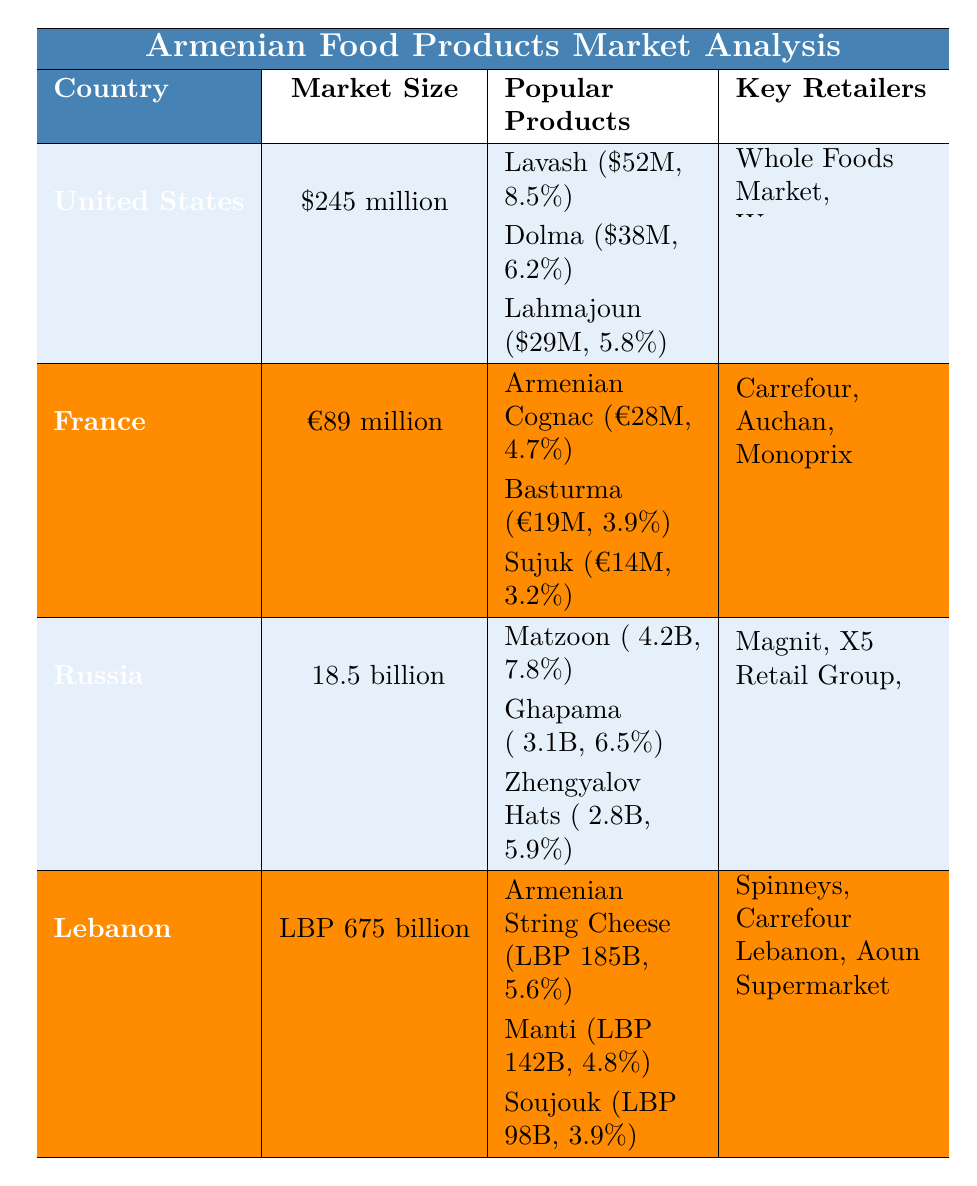What is the market size for Armenian food products in the United States? According to the table, the market size for Armenian food products in the United States is stated as $245 million.
Answer: $245 million Which Armenian food product has the highest annual sales in France? The table lists Armenian Cognac as the product with the highest annual sales in France at €28 million.
Answer: Armenian Cognac What is the total annual sales for popular Armenian products in Lebanon? The annual sales for three products in Lebanon are LBP 185 billion (Armenian String Cheese), LBP 142 billion (Manti), and LBP 98 billion (Soujouk). Summing these gives: 185 + 142 + 98 = 425 billion LBP.
Answer: LBP 425 billion Is the growth rate for Dolma in the United States higher than that of Basturma in France? The growth rate for Dolma in the United States is 6.2%, while Basturma in France has a growth rate of 3.9%. Since 6.2% > 3.9%, the statement is true.
Answer: Yes Which country's Armenian food products market has the highest growth rate for its most popular product? In Russia, Matzoon has a growth rate of 7.8%, which is higher than the highest growth rates of the popular products in the other countries: 8.5% (Lavash in the US), 4.7% (Armenian Cognac in France), and 5.6% (Armenian String Cheese in Lebanon). Thus, Russia has the highest growth rate for its most popular product.
Answer: Russia What is the average growth rate of the popular products listed for the United States? The growth rates for the three popular products in the United States are 8.5%, 6.2%, and 5.8%. The average is calculated as (8.5 + 6.2 + 5.8) / 3 = 6.5%.
Answer: 6.5% Which product in Russia has the lowest annual sales? In Russia, Zhengyalov Hats has the lowest annual sales at ₽2.8 billion compared to Matzoon (₽4.2 billion) and Ghapama (₽3.1 billion).
Answer: Zhengyalov Hats What is the market size for Armenian food products in Lebanon compared to that of France? Lebanon's market size is LBP 675 billion, while France's market size is €89 million. Since these amounts are in different currencies, we cannot directly compare them; however, numerically, LBP 675 billion is significantly larger than €89 million.
Answer: LBP 675 billion is larger Which retailer is common in both the United States and Lebanon? The retailers listed for the United States are Whole Foods Market, Wegmans, and Trader Joe's, while those in Lebanon are Spinneys, Carrefour Lebanon, and Aoun Supermarket. The only retailer that appears in another country is Carrefour, which is present in both France and Lebanon, but not in the United States. Thus, none of the retailers are common between the US and Lebanon.
Answer: No common retailer If we sum the annual sales of the most popular products across all countries, what will be the total? Summing the sales: US - Lavash ($52M) + Dolma ($38M) + Lahmajoun ($29M) + France - Armenian Cognac (€28M) + Basturma (€19M) + Sujuk (€14M) + Russia - Matzoon (₽4.2B) + Ghapama (₽3.1B) + Zhengyalov Hats (₽2.8B) + Lebanon - Armenian String Cheese (LBP 185B) + Manti (LBP 142B) + Soujouk (LBP 98B). To compare them accurately, convert to a common currency or express as totals separately.
Answer: Total varies by currency 